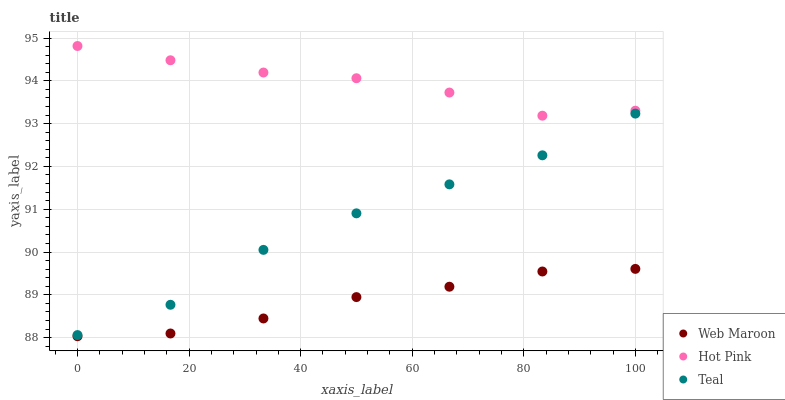Does Web Maroon have the minimum area under the curve?
Answer yes or no. Yes. Does Hot Pink have the maximum area under the curve?
Answer yes or no. Yes. Does Teal have the minimum area under the curve?
Answer yes or no. No. Does Teal have the maximum area under the curve?
Answer yes or no. No. Is Web Maroon the smoothest?
Answer yes or no. Yes. Is Teal the roughest?
Answer yes or no. Yes. Is Teal the smoothest?
Answer yes or no. No. Is Web Maroon the roughest?
Answer yes or no. No. Does Web Maroon have the lowest value?
Answer yes or no. Yes. Does Teal have the lowest value?
Answer yes or no. No. Does Hot Pink have the highest value?
Answer yes or no. Yes. Does Teal have the highest value?
Answer yes or no. No. Is Web Maroon less than Teal?
Answer yes or no. Yes. Is Hot Pink greater than Teal?
Answer yes or no. Yes. Does Web Maroon intersect Teal?
Answer yes or no. No. 